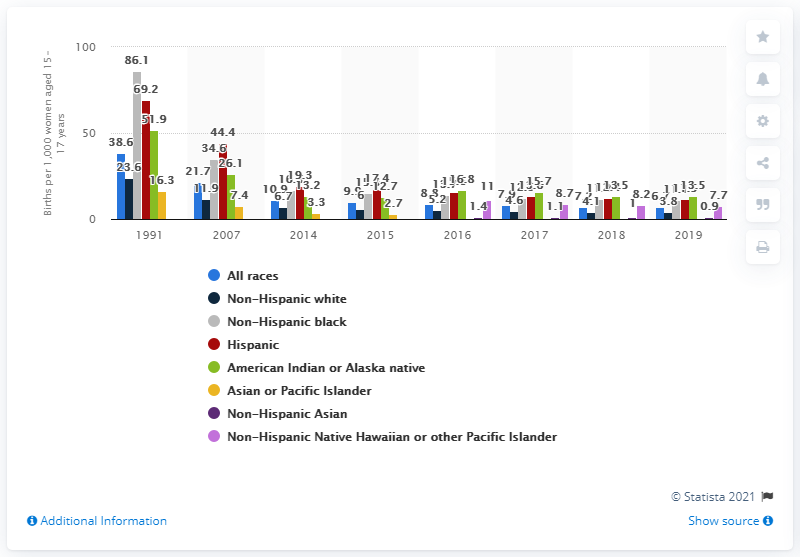Mention a couple of crucial points in this snapshot. The birth rate for Hispanic women in the same age group in 2019 was 11.5. 